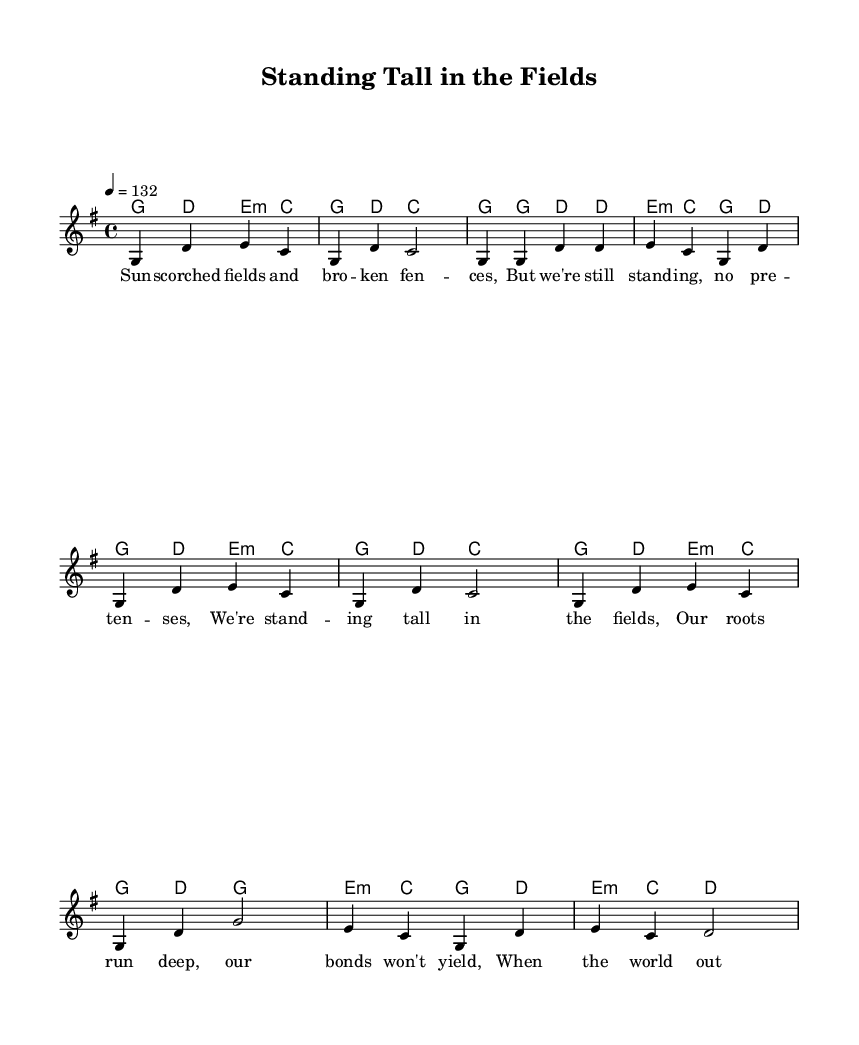What is the key signature of this music? The key signature is G major, which has one sharp (F#). You can identify this by looking at the key signature at the beginning of the sheet music, which indicates the pitches used in the composition.
Answer: G major What is the time signature of this music? The time signature is 4/4, meaning there are four beats per measure, and the quarter note gets one beat. This is found at the start of the sheet music, which indicates how the rhythm is organized.
Answer: 4/4 What is the tempo marking of this music? The tempo marking is 132 BPM (beats per minute). This can be determined by looking for the tempo indication at the beginning of the piece, which specifies the speed at which the music should be played.
Answer: 132 How many measures are included in the chorus? The chorus contains four measures, which can be counted by identifying the sections marked in the sheet music. By examining the notation, we can see the grouping of notes that form each measure.
Answer: 4 What musical style does this piece represent? This piece represents Country Rock as indicated by the energetic melody, upbeat rhythm, and common themes focusing on rural life and community strength, characteristic of this genre.
Answer: Country Rock What is the main theme expressed in the lyrics? The main theme expressed in the lyrics is resilience and unity, highlighting the strength of rural communities in tough times, as reflected in the words and the imagery used throughout the verses.
Answer: Resilience and unity 